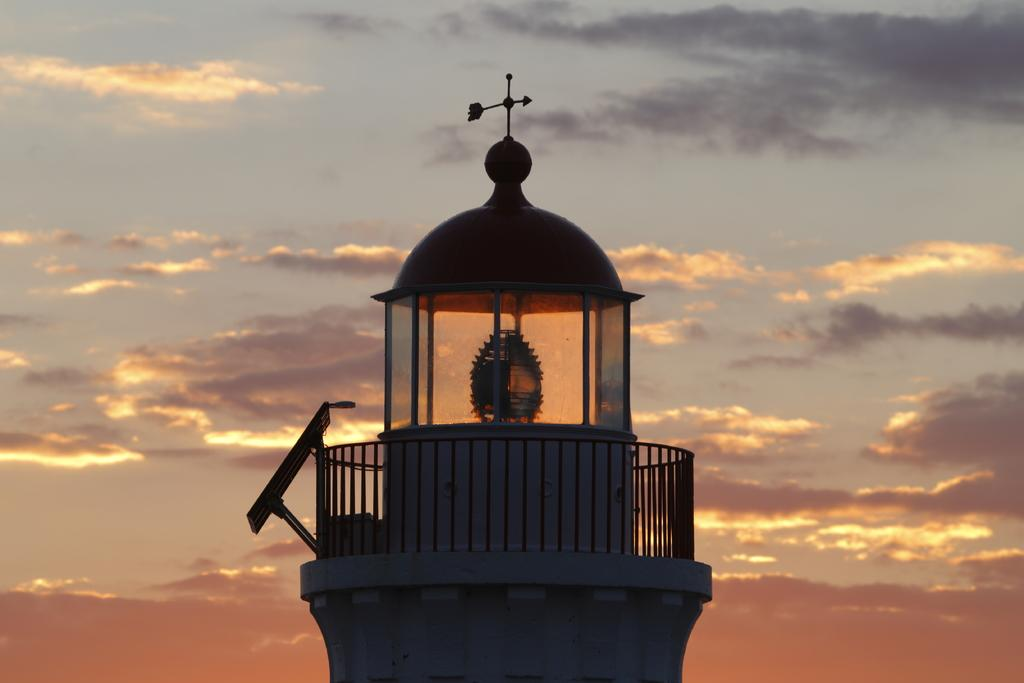What is the main structure in the picture? There is a lighthouse in the picture. How would you describe the sky in the background? The sky in the background is cloudy. What type of party is happening near the lighthouse in the image? There is no party visible in the image; it only features a lighthouse and a cloudy sky. How many oranges can be seen hanging from the lighthouse in the image? There are no oranges present in the image. 